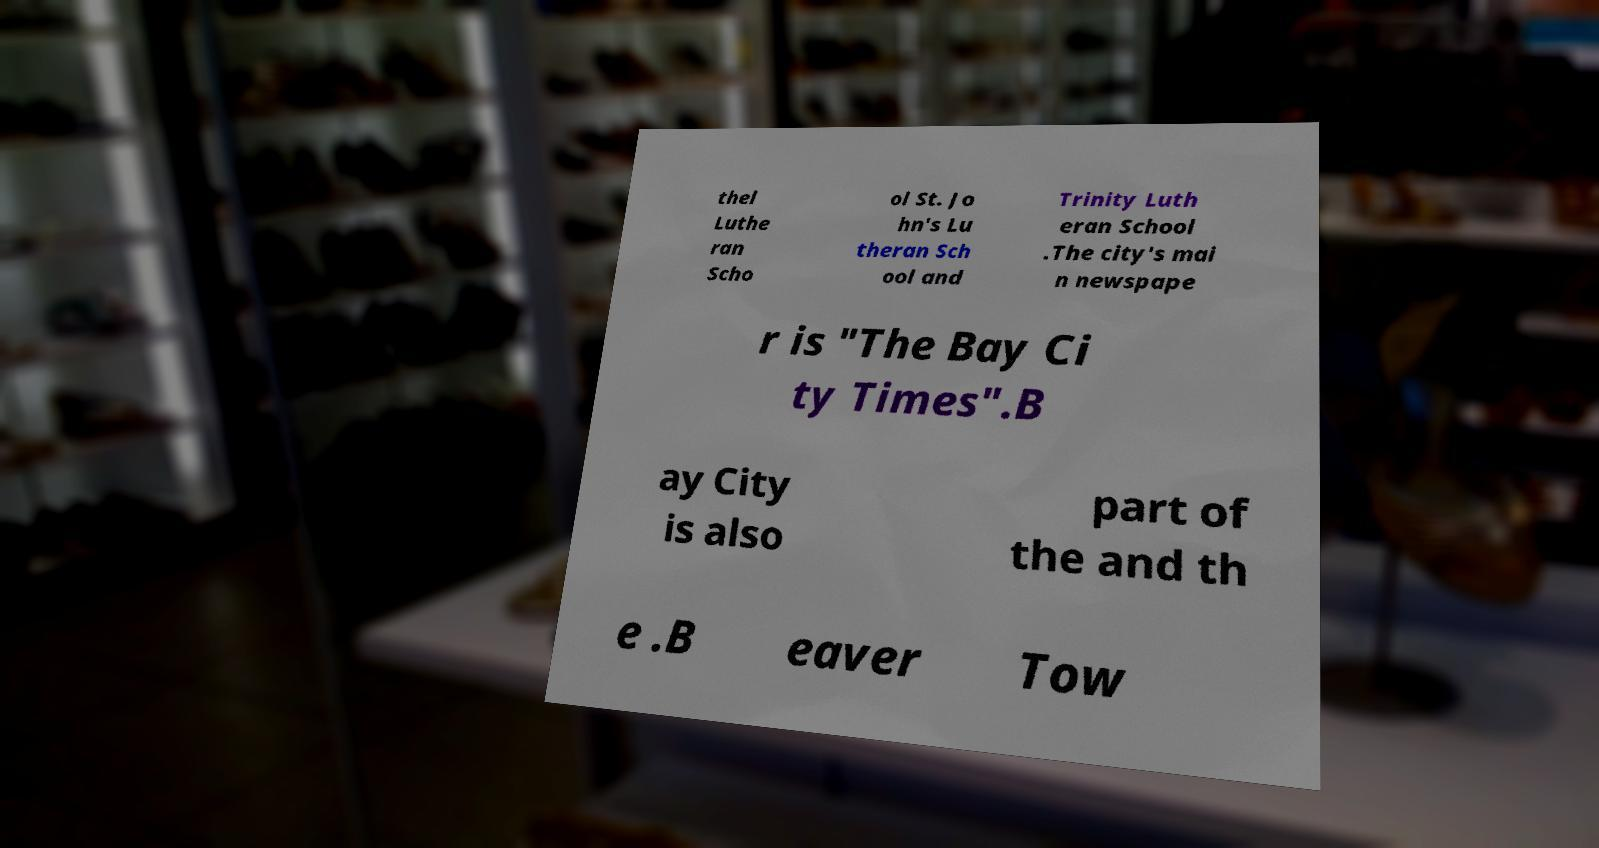Please read and relay the text visible in this image. What does it say? thel Luthe ran Scho ol St. Jo hn's Lu theran Sch ool and Trinity Luth eran School .The city's mai n newspape r is "The Bay Ci ty Times".B ay City is also part of the and th e .B eaver Tow 